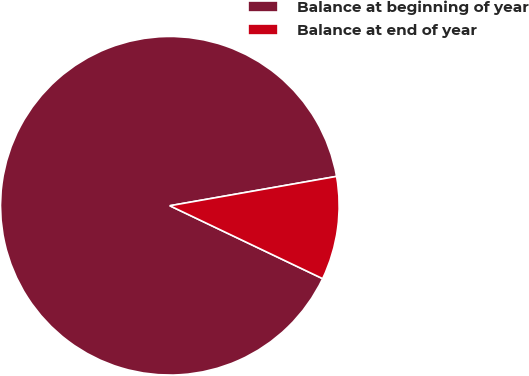Convert chart. <chart><loc_0><loc_0><loc_500><loc_500><pie_chart><fcel>Balance at beginning of year<fcel>Balance at end of year<nl><fcel>90.14%<fcel>9.86%<nl></chart> 